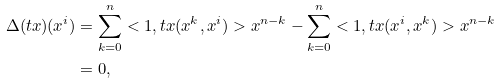<formula> <loc_0><loc_0><loc_500><loc_500>\Delta ( t x ) ( x ^ { i } ) & = \sum _ { k = 0 } ^ { n } < 1 , t x ( x ^ { k } , x ^ { i } ) > x ^ { n - k } - \sum _ { k = 0 } ^ { n } < 1 , t x ( x ^ { i } , x ^ { k } ) > x ^ { n - k } \\ & = 0 , \\</formula> 